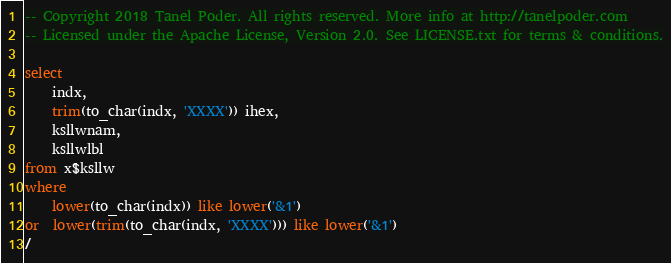<code> <loc_0><loc_0><loc_500><loc_500><_SQL_>-- Copyright 2018 Tanel Poder. All rights reserved. More info at http://tanelpoder.com
-- Licensed under the Apache License, Version 2.0. See LICENSE.txt for terms & conditions.

select 
    indx,
    trim(to_char(indx, 'XXXX')) ihex,
    ksllwnam, 
    ksllwlbl 
from x$ksllw 
where 
    lower(to_char(indx)) like lower('&1')
or  lower(trim(to_char(indx, 'XXXX'))) like lower('&1')
/</code> 